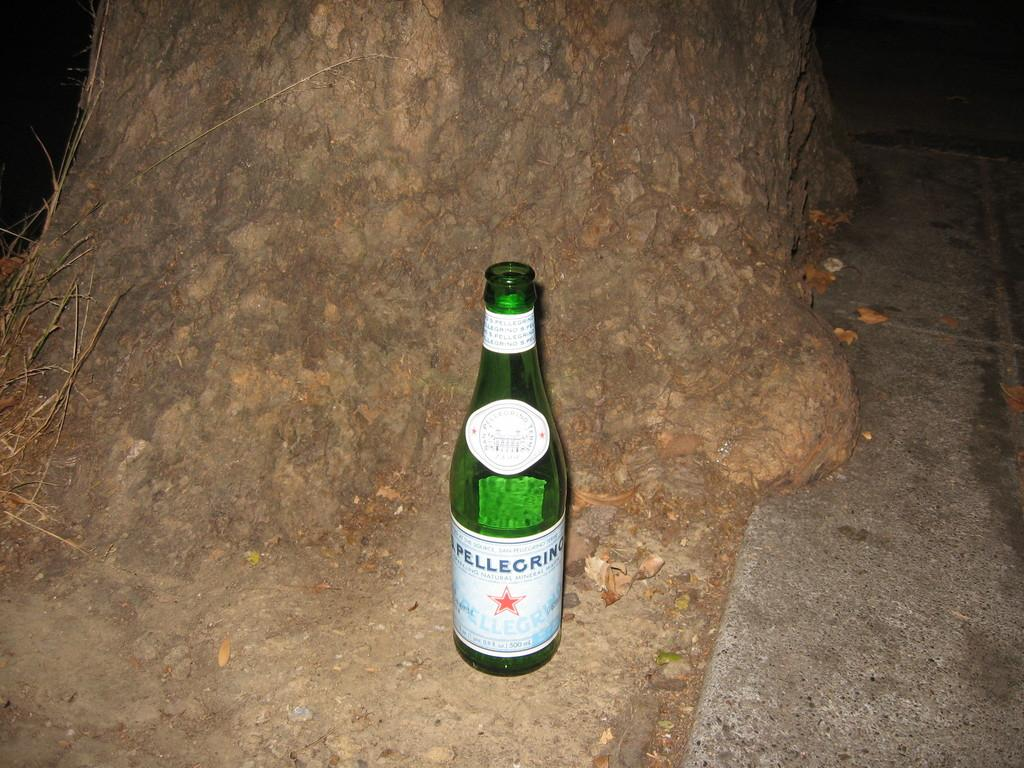<image>
Share a concise interpretation of the image provided. An open green bottle of Pellegrino sitting outside at night 